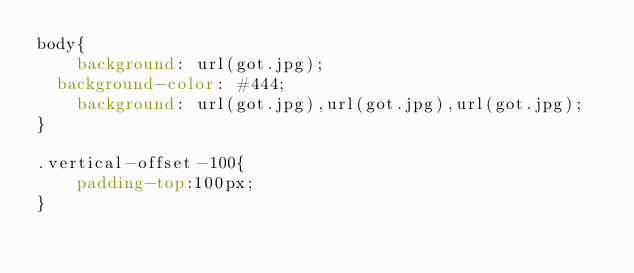Convert code to text. <code><loc_0><loc_0><loc_500><loc_500><_CSS_>body{
    background: url(got.jpg);
	background-color: #444;
    background: url(got.jpg),url(got.jpg),url(got.jpg);
}

.vertical-offset-100{
    padding-top:100px;
}

</code> 